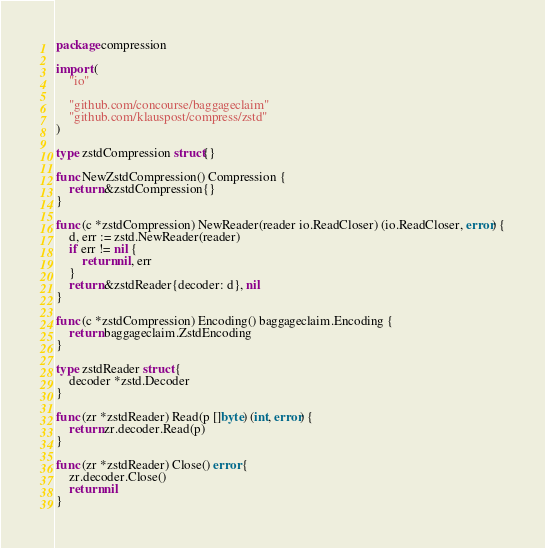Convert code to text. <code><loc_0><loc_0><loc_500><loc_500><_Go_>package compression

import (
	"io"

	"github.com/concourse/baggageclaim"
	"github.com/klauspost/compress/zstd"
)

type zstdCompression struct{}

func NewZstdCompression() Compression {
	return &zstdCompression{}
}

func (c *zstdCompression) NewReader(reader io.ReadCloser) (io.ReadCloser, error) {
	d, err := zstd.NewReader(reader)
	if err != nil {
		return nil, err
	}
	return &zstdReader{decoder: d}, nil
}

func (c *zstdCompression) Encoding() baggageclaim.Encoding {
	return baggageclaim.ZstdEncoding
}

type zstdReader struct {
	decoder *zstd.Decoder
}

func (zr *zstdReader) Read(p []byte) (int, error) {
	return zr.decoder.Read(p)
}

func (zr *zstdReader) Close() error {
	zr.decoder.Close()
	return nil
}
</code> 